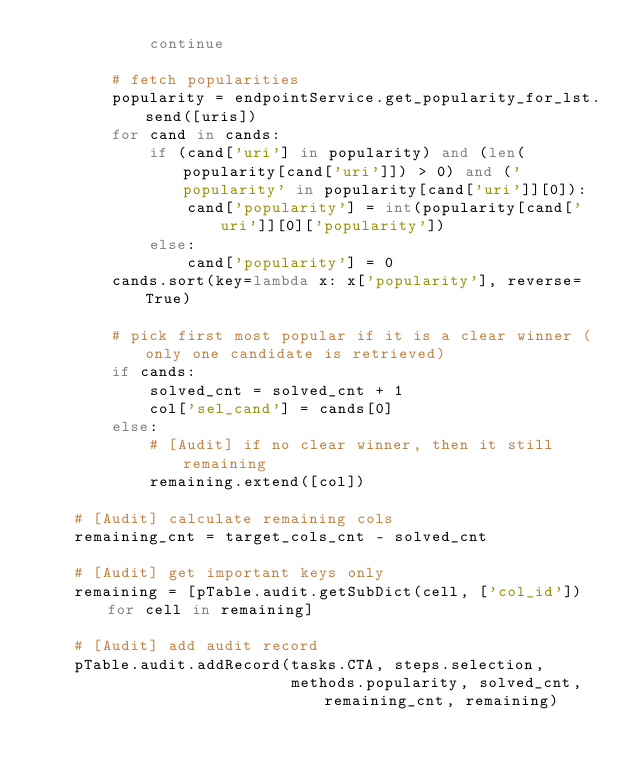Convert code to text. <code><loc_0><loc_0><loc_500><loc_500><_Python_>            continue

        # fetch popularities
        popularity = endpointService.get_popularity_for_lst.send([uris])
        for cand in cands:
            if (cand['uri'] in popularity) and (len(popularity[cand['uri']]) > 0) and ('popularity' in popularity[cand['uri']][0]):
                cand['popularity'] = int(popularity[cand['uri']][0]['popularity'])
            else:
                cand['popularity'] = 0
        cands.sort(key=lambda x: x['popularity'], reverse=True)

        # pick first most popular if it is a clear winner (only one candidate is retrieved)
        if cands:
            solved_cnt = solved_cnt + 1
            col['sel_cand'] = cands[0]
        else:
            # [Audit] if no clear winner, then it still remaining
            remaining.extend([col])

    # [Audit] calculate remaining cols
    remaining_cnt = target_cols_cnt - solved_cnt

    # [Audit] get important keys only
    remaining = [pTable.audit.getSubDict(cell, ['col_id']) for cell in remaining]

    # [Audit] add audit record
    pTable.audit.addRecord(tasks.CTA, steps.selection,
                           methods.popularity, solved_cnt, remaining_cnt, remaining)
</code> 